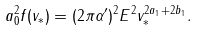<formula> <loc_0><loc_0><loc_500><loc_500>a ^ { 2 } _ { 0 } f ( v _ { \ast } ) = ( 2 \pi \alpha ^ { \prime } ) ^ { 2 } E ^ { 2 } v ^ { 2 a _ { 1 } + 2 b _ { 1 } } _ { \ast } .</formula> 